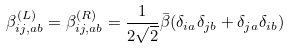<formula> <loc_0><loc_0><loc_500><loc_500>\beta ^ { ( L ) } _ { i j , a b } = \beta ^ { ( R ) } _ { i j , a b } = \frac { 1 } { 2 \sqrt { 2 } } \bar { \beta } ( \delta _ { i a } \delta _ { j b } + \delta _ { j a } \delta _ { i b } )</formula> 